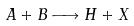<formula> <loc_0><loc_0><loc_500><loc_500>A + B \longrightarrow H + X</formula> 